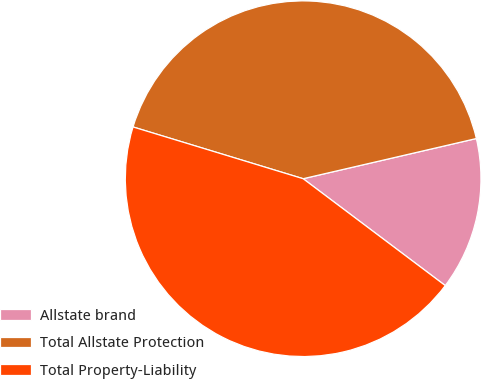<chart> <loc_0><loc_0><loc_500><loc_500><pie_chart><fcel>Allstate brand<fcel>Total Allstate Protection<fcel>Total Property-Liability<nl><fcel>13.89%<fcel>41.67%<fcel>44.44%<nl></chart> 